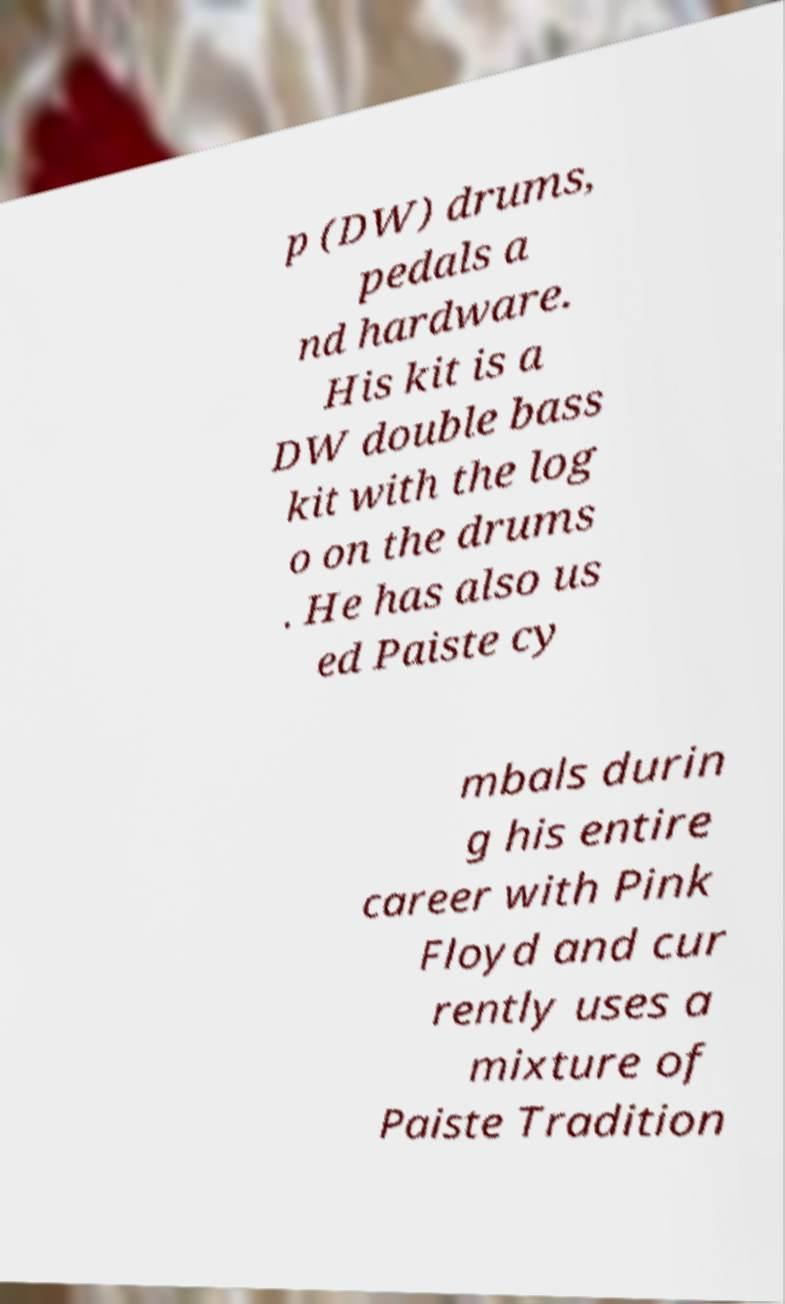Please identify and transcribe the text found in this image. p (DW) drums, pedals a nd hardware. His kit is a DW double bass kit with the log o on the drums . He has also us ed Paiste cy mbals durin g his entire career with Pink Floyd and cur rently uses a mixture of Paiste Tradition 